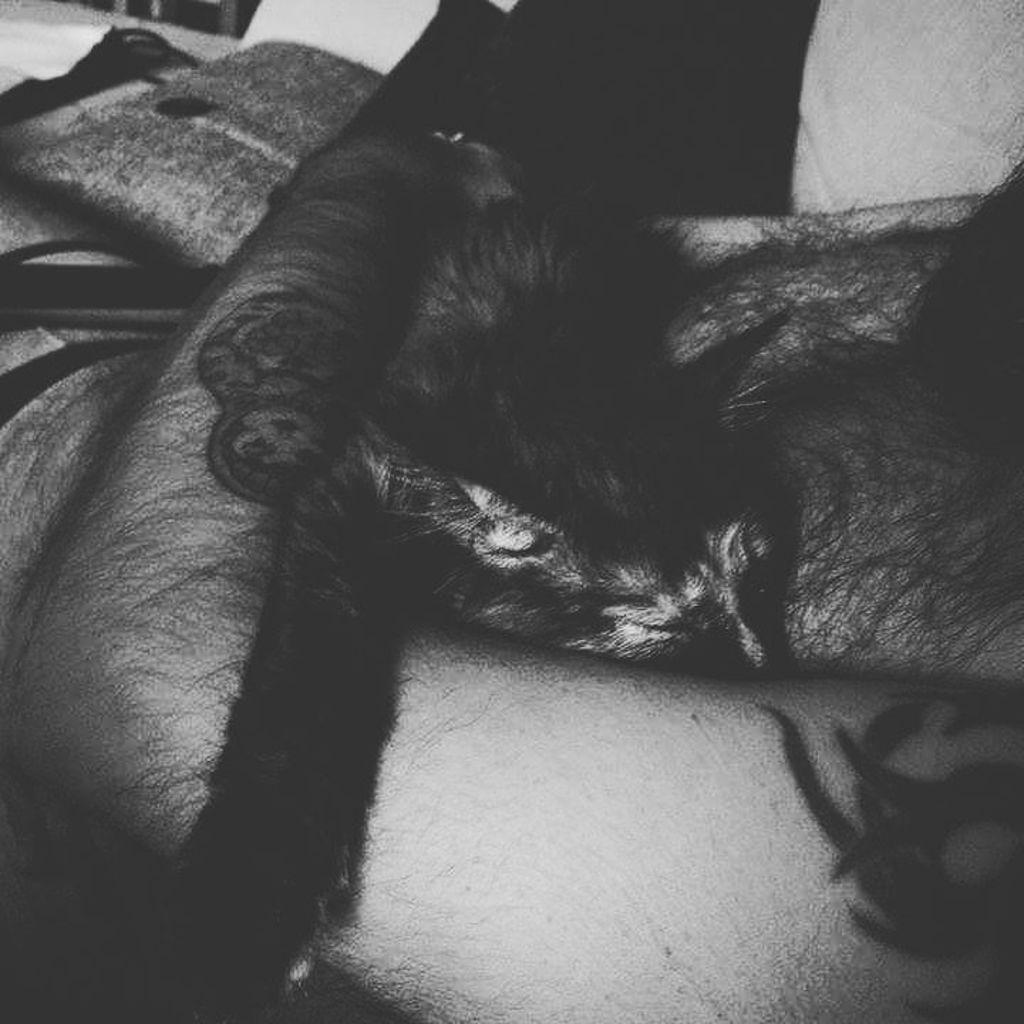What is the main subject of the image? There is a person in the image. What is the person holding in the image? The person is holding a cat. What color scheme is used in the image? The image is in black and white. What type of coal is being used as an ornament in the image? There is no coal or ornament present in the image; it features a person holding a cat in a black and white setting. Is the person in the image sleeping? The image does not show the person sleeping; they are holding a cat. 